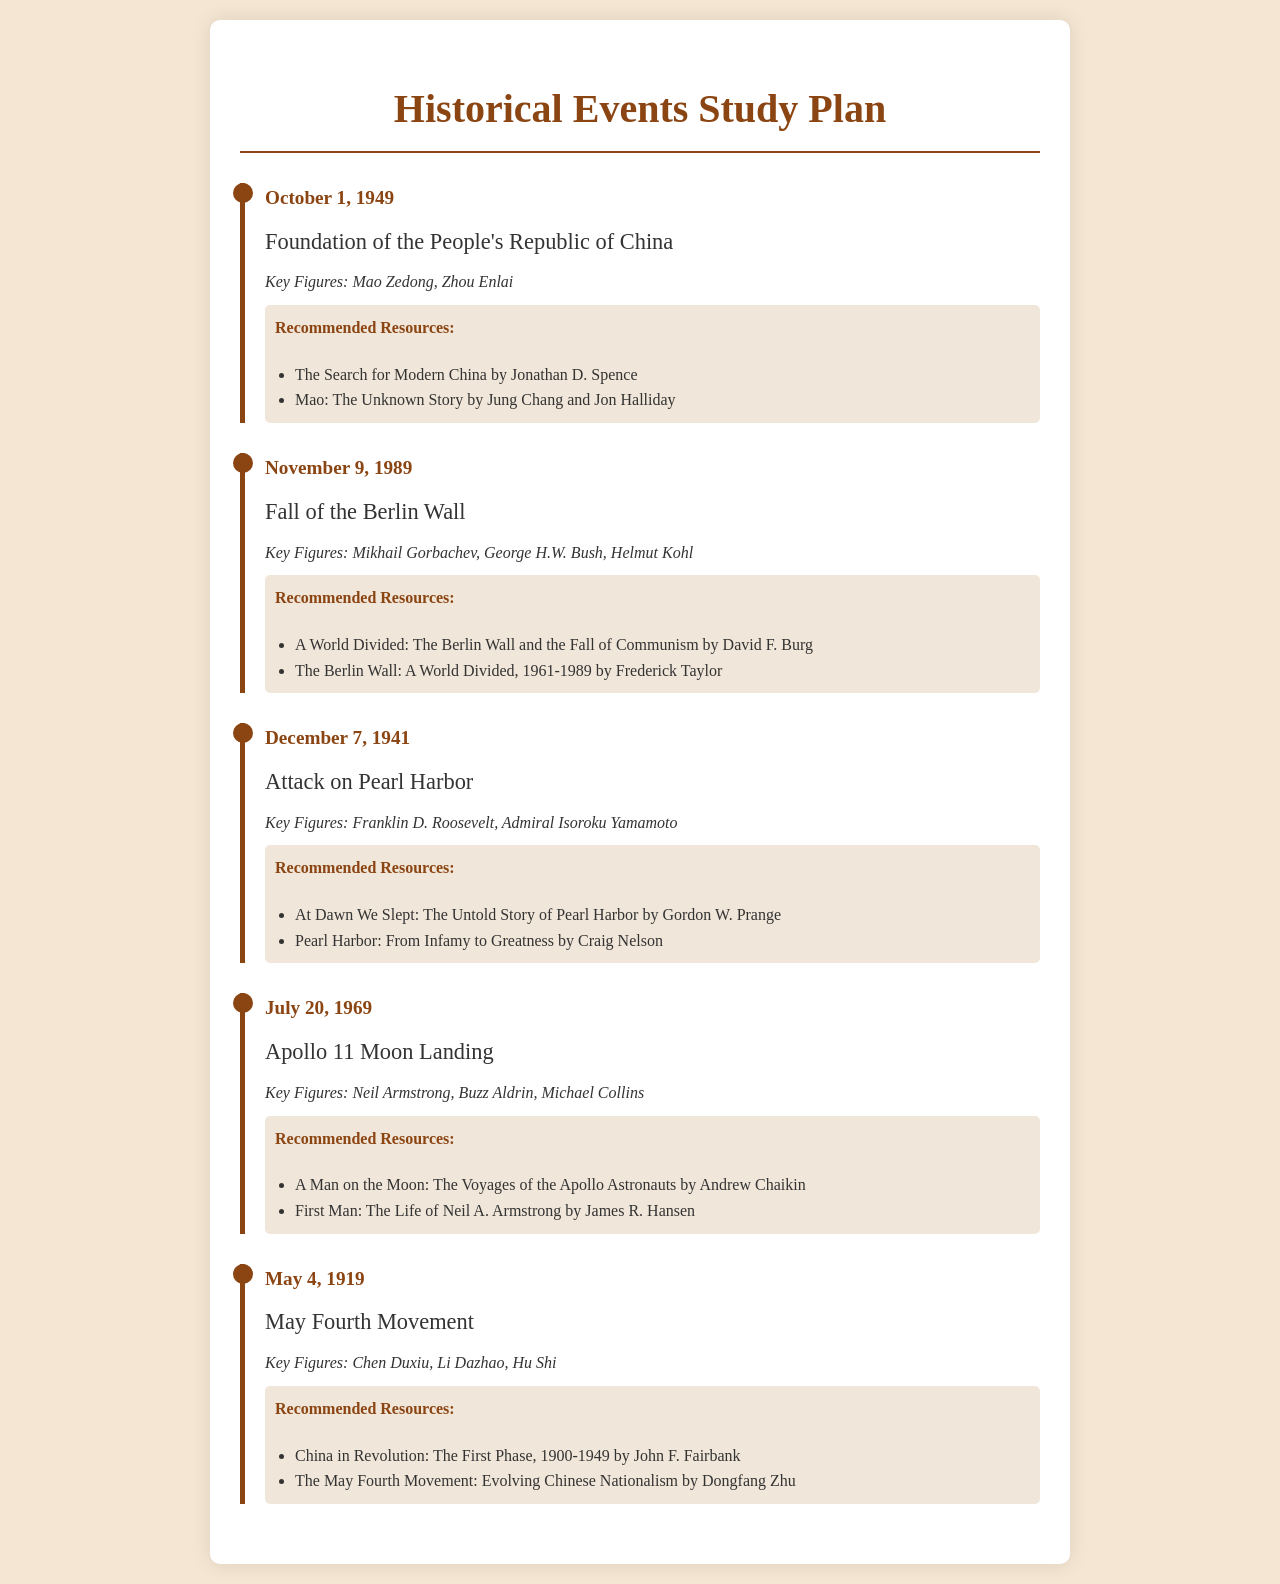What event occurred on October 1, 1949? The document identifies the Foundation of the People's Republic of China as the event on this date.
Answer: Foundation of the People's Republic of China Who are the key figures associated with the May Fourth Movement? The document lists Chen Duxiu, Li Dazhao, and Hu Shi as key figures of this movement.
Answer: Chen Duxiu, Li Dazhao, Hu Shi What date marks the Attack on Pearl Harbor? The document specifies December 7, 1941, as the date of the Attack on Pearl Harbor.
Answer: December 7, 1941 Which event is linked to Neil Armstrong? Neil Armstrong is noted for his involvement in the Apollo 11 Moon Landing.
Answer: Apollo 11 Moon Landing What book is recommended for studying the Fall of the Berlin Wall? The recommended resource is "A World Divided: The Berlin Wall and the Fall of Communism" by David F. Burg.
Answer: A World Divided: The Berlin Wall and the Fall of Communism How many key figures are mentioned for the Apollo 11 Moon Landing? The document states three key figures: Neil Armstrong, Buzz Aldrin, and Michael Collins.
Answer: Three What historical movement took place on May 4, 1919? The document indicates the May Fourth Movement occurred on this date.
Answer: May Fourth Movement Who wrote "Mao: The Unknown Story"? The author listed is Jung Chang and Jon Halliday as the writers of this book.
Answer: Jung Chang and Jon Halliday What significant event took place on July 20, 1969? The Apollo 11 Moon Landing is the significant event that occurred on this date.
Answer: Apollo 11 Moon Landing 